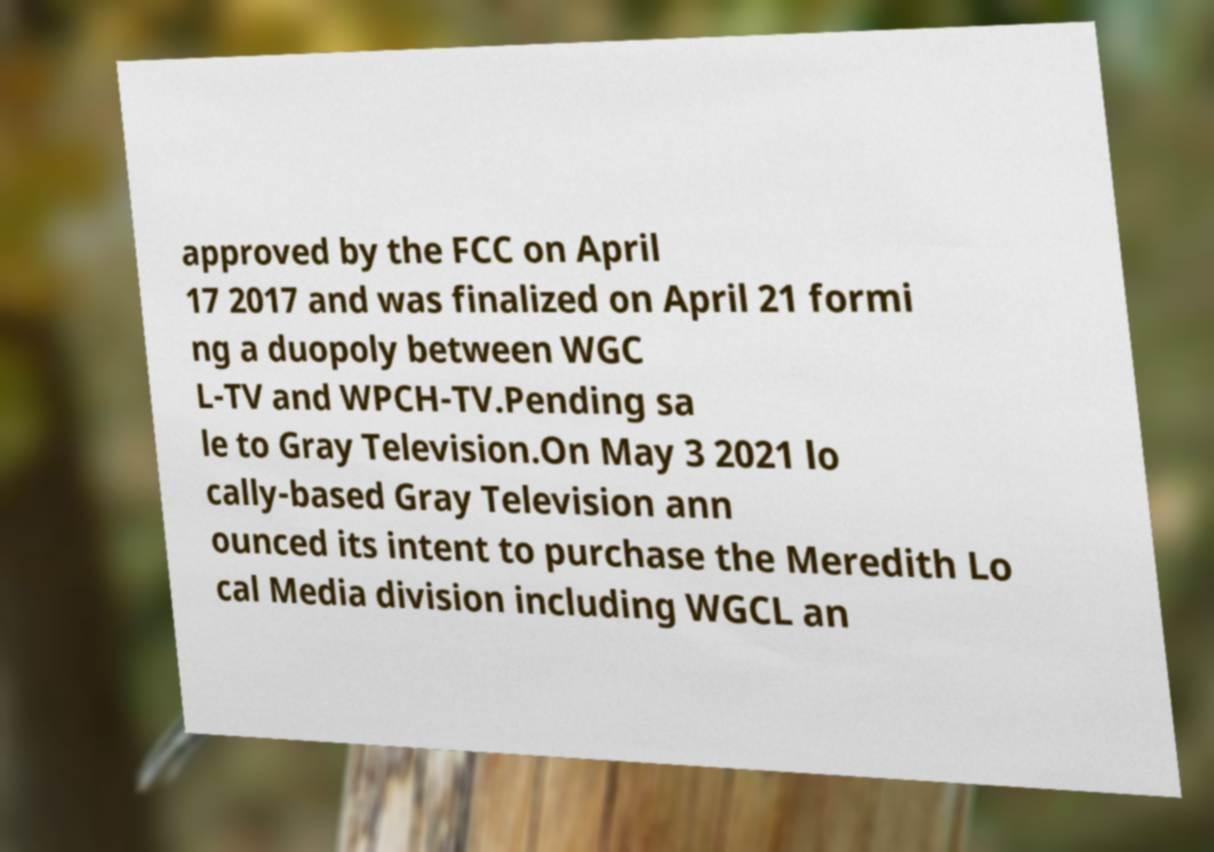There's text embedded in this image that I need extracted. Can you transcribe it verbatim? approved by the FCC on April 17 2017 and was finalized on April 21 formi ng a duopoly between WGC L-TV and WPCH-TV.Pending sa le to Gray Television.On May 3 2021 lo cally-based Gray Television ann ounced its intent to purchase the Meredith Lo cal Media division including WGCL an 